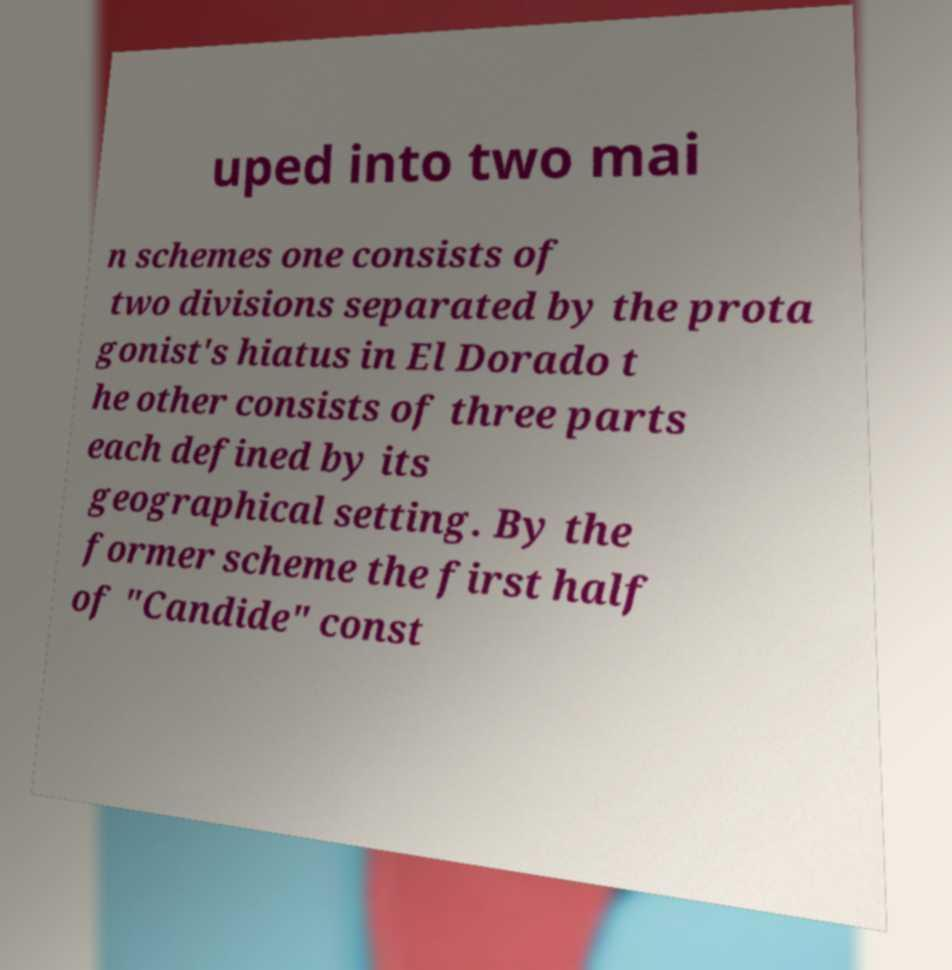Could you assist in decoding the text presented in this image and type it out clearly? uped into two mai n schemes one consists of two divisions separated by the prota gonist's hiatus in El Dorado t he other consists of three parts each defined by its geographical setting. By the former scheme the first half of "Candide" const 